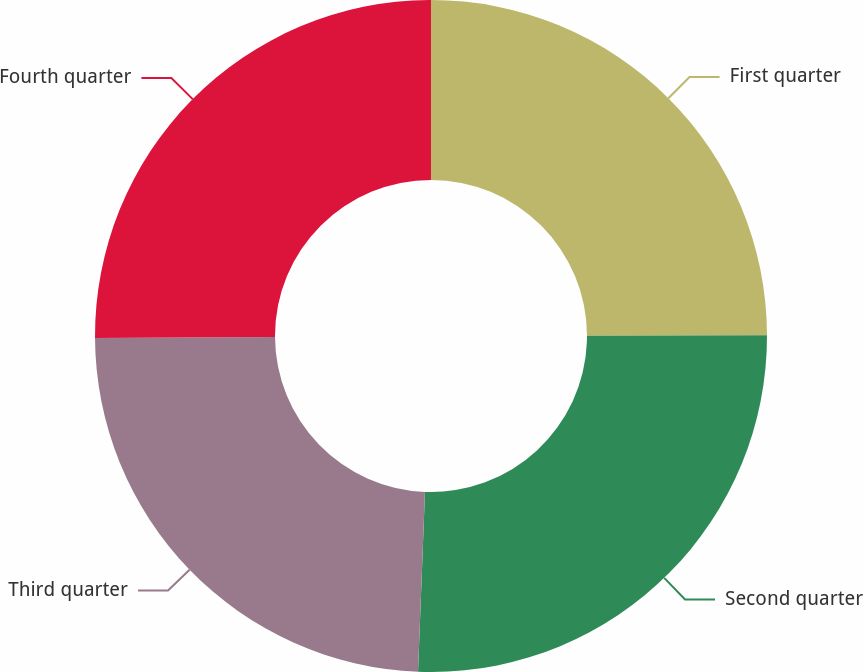Convert chart to OTSL. <chart><loc_0><loc_0><loc_500><loc_500><pie_chart><fcel>First quarter<fcel>Second quarter<fcel>Third quarter<fcel>Fourth quarter<nl><fcel>24.97%<fcel>25.65%<fcel>24.29%<fcel>25.1%<nl></chart> 